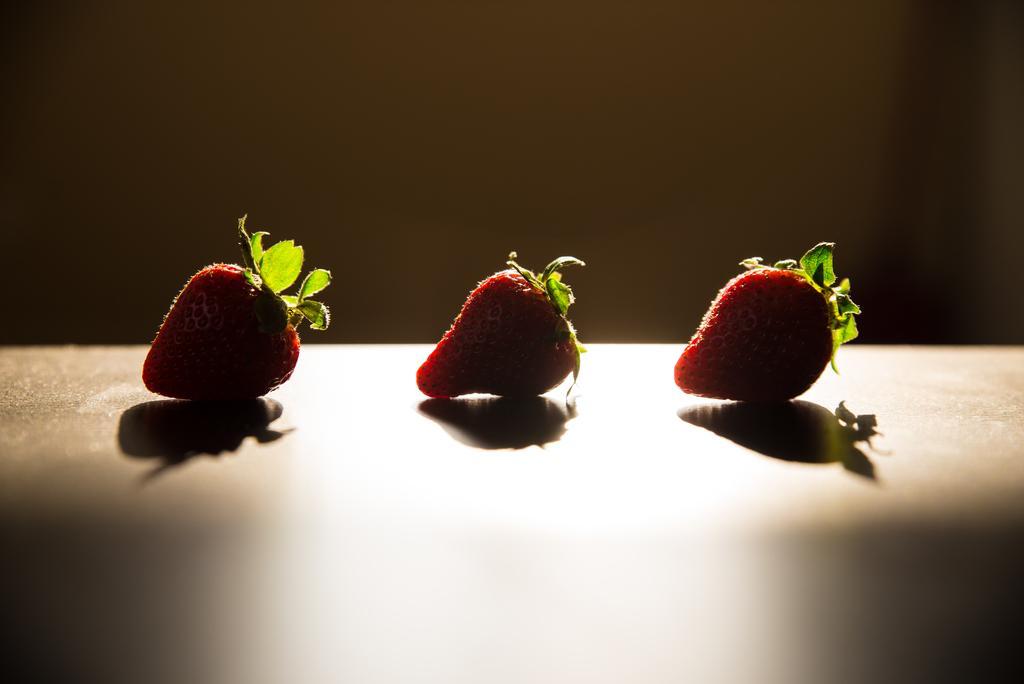In one or two sentences, can you explain what this image depicts? There are three strawberries kept on the surface as we can see in the middle of this image, and it seems like a wall in the background. 